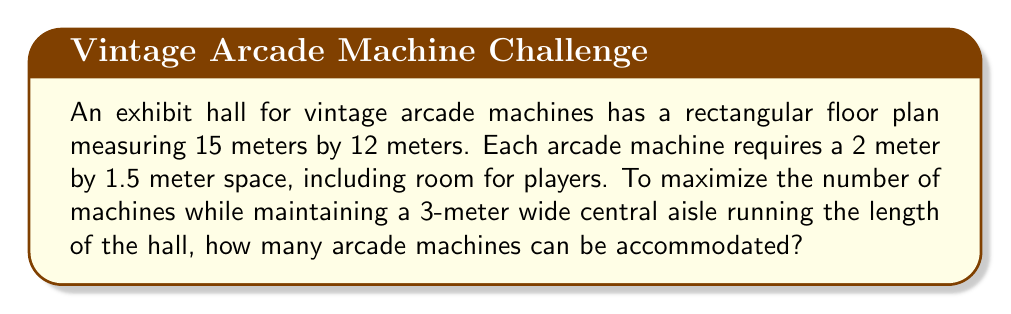Solve this math problem. Let's approach this step-by-step:

1) First, let's visualize the layout:
   [asy]
   unitsize(0.2cm);
   draw((0,0)--(75,0)--(75,60)--(0,60)--cycle);
   draw((0,30)--(75,30),dashed);
   label("15m",(-2,30),W);
   label("12m",(37.5,62),N);
   label("3m",(37.5,33),S);
   [/asy]

2) The central aisle takes up 3m of the 12m width, leaving 4.5m on each side for machines.

3) Each machine requires 1.5m in width. We can fit:
   $\frac{4.5m}{1.5m} = 3$ machines in width on each side.

4) Each machine requires 2m in length. The hall is 15m long, so we can fit:
   $\frac{15m}{2m} = 7.5$ machines in length.
   We round down to 7 as we can't have partial machines.

5) Now we can calculate the total number of machines:
   $$(3 \text{ machines per side}) \times (2 \text{ sides}) \times (7 \text{ machines in length}) = 42 \text{ machines}$$

Therefore, the exhibit can accommodate 42 vintage arcade machines while maintaining the central aisle.
Answer: 42 machines 